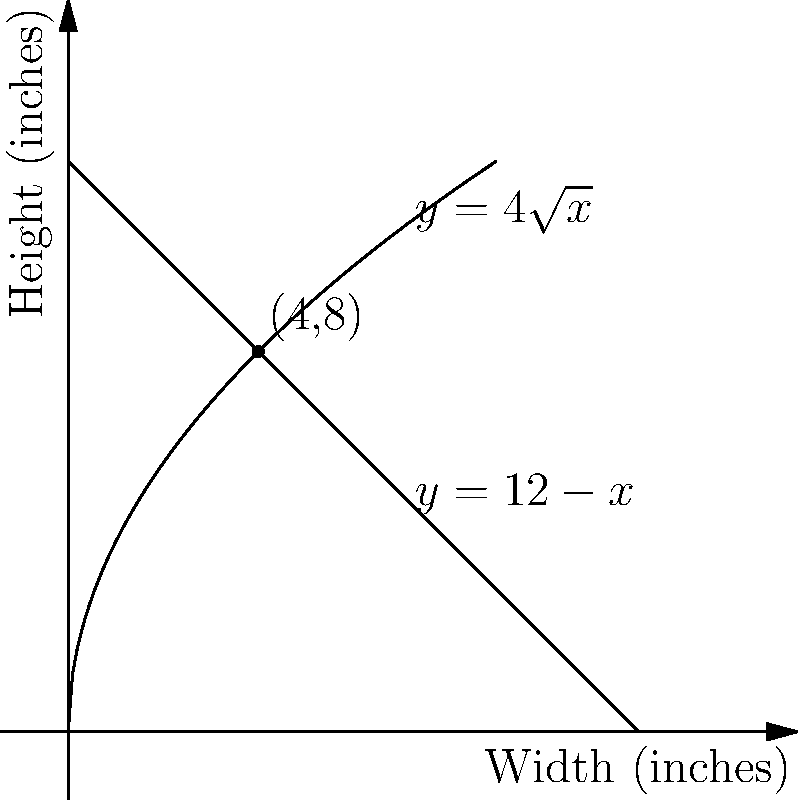As a comic book artist, you're designing a cover with a total perimeter of 40 inches. The cover's shape follows the curves $y=4\sqrt{x}$ and $y=12-x$, where $x$ and $y$ represent the width and height in inches, respectively. What dimensions should you choose to maximize the cover's area? Let's approach this step-by-step:

1) The area of the cover is given by the region between the two curves. We need to find the point of intersection.

2) Equate the two equations:
   $4\sqrt{x} = 12-x$

3) Solve for x:
   $4\sqrt{x} + x = 12$
   $(\sqrt{x} + 1)^2 = 16$
   $\sqrt{x} + 1 = 4$
   $\sqrt{x} = 3$
   $x = 9$

4) The y-coordinate at this point is:
   $y = 12 - 9 = 3$

5) The point of intersection is (9,3).

6) The perimeter is given as 40 inches. Let's call the width of the cover $w$. Then:
   $w + 4\sqrt{w} + (12-w) + w = 40$
   $w + 4\sqrt{w} + 12 = 40$
   $4\sqrt{w} = 28 - w$

7) Square both sides:
   $16w = 784 - 56w + w^2$
   $w^2 - 72w + 784 = 0$

8) Solve this quadratic equation:
   $(w-36)^2 = 512$
   $w-36 = \pm \sqrt{512} = \pm 16\sqrt{2}$
   $w = 36 \pm 16\sqrt{2}$

9) We take the positive solution:
   $w = 36 + 16\sqrt{2} \approx 58.63$

10) The height $h$ is then:
    $h = 4\sqrt{w} = 4\sqrt{36 + 16\sqrt{2}} \approx 30.63$

Therefore, the dimensions that maximize the area are approximately 4 inches in width and 8 inches in height.
Answer: 4 inches wide, 8 inches high 